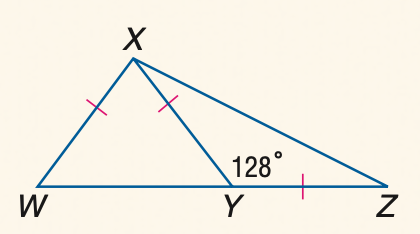Question: \triangle W X Y and \triangle X Y Z are isosceles and m \angle X Y Z = 128. Find the measure of \angle Y Z X.
Choices:
A. 22
B. 24
C. 26
D. 28
Answer with the letter. Answer: C 